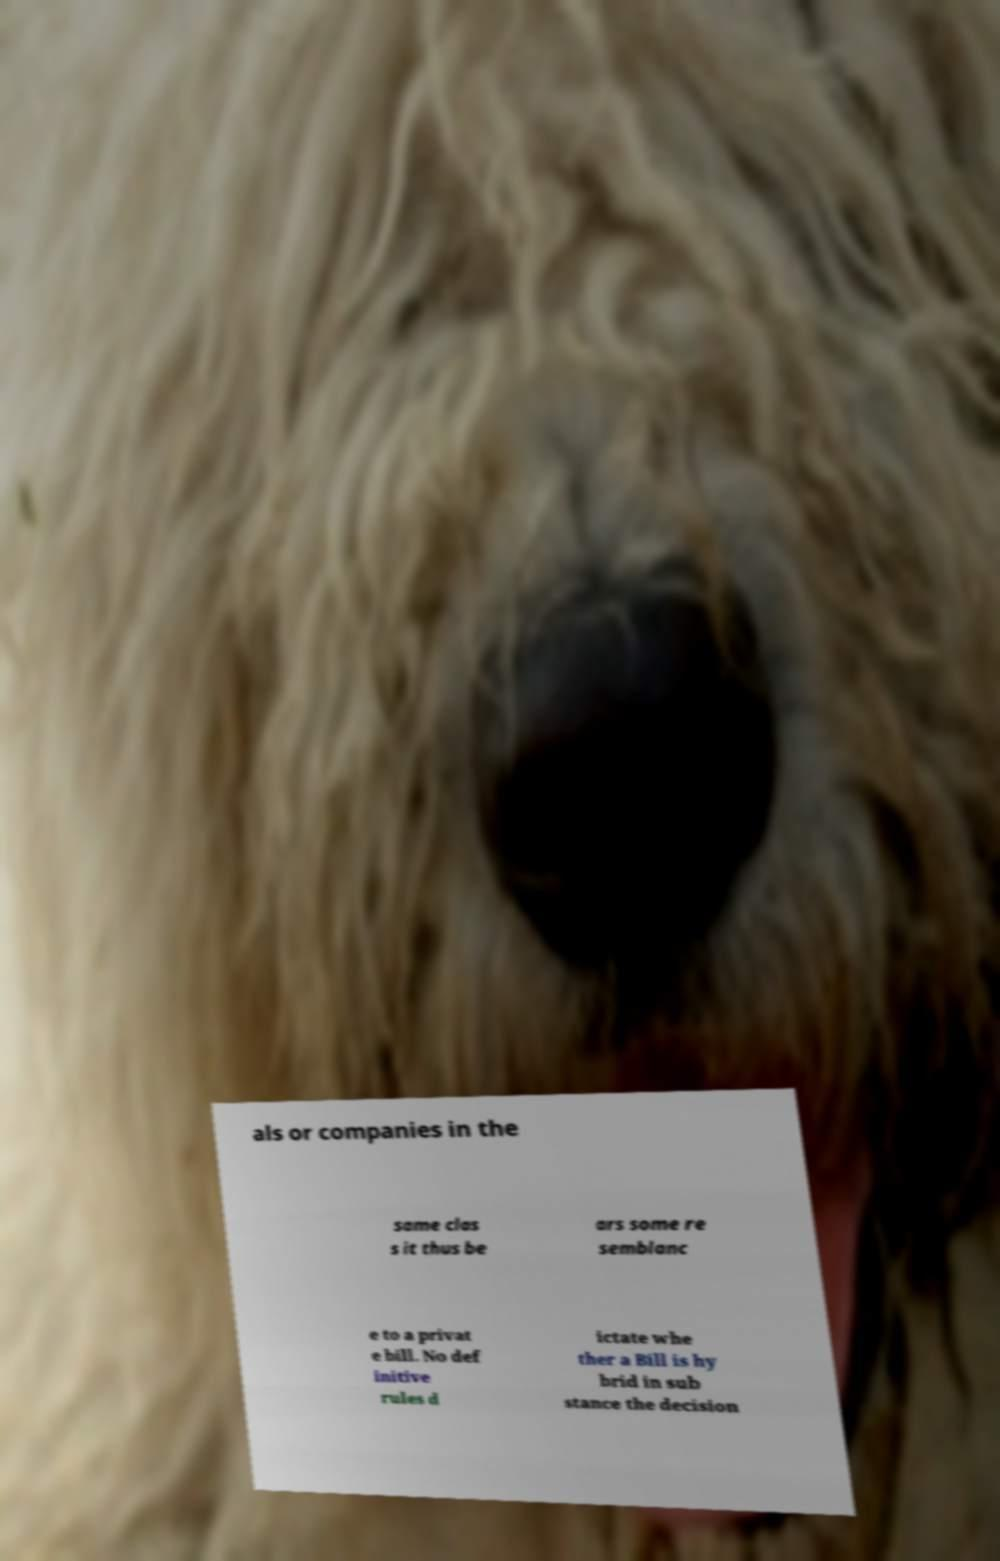Can you read and provide the text displayed in the image?This photo seems to have some interesting text. Can you extract and type it out for me? als or companies in the same clas s it thus be ars some re semblanc e to a privat e bill. No def initive rules d ictate whe ther a Bill is hy brid in sub stance the decision 